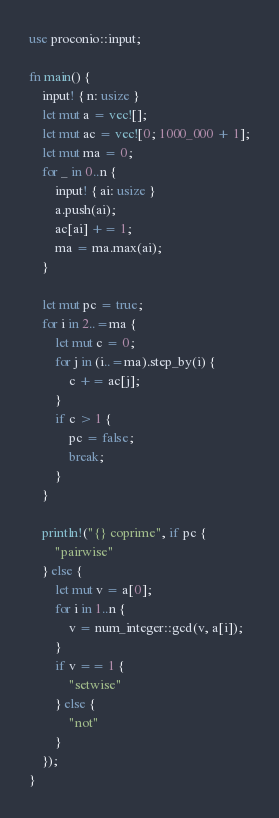Convert code to text. <code><loc_0><loc_0><loc_500><loc_500><_Rust_>use proconio::input;

fn main() {
    input! { n: usize }
    let mut a = vec![];
    let mut ac = vec![0; 1000_000 + 1];
    let mut ma = 0;
    for _ in 0..n {
        input! { ai: usize }
        a.push(ai);
        ac[ai] += 1;
        ma = ma.max(ai);
    }

    let mut pc = true;
    for i in 2..=ma {
        let mut c = 0;
        for j in (i..=ma).step_by(i) {
            c += ac[j];
        }
        if c > 1 {
            pc = false;
            break;
        }
    }

    println!("{} coprime", if pc {
        "pairwise"
    } else {
        let mut v = a[0];
        for i in 1..n {
            v = num_integer::gcd(v, a[i]);
        }
        if v == 1 {
            "setwise"
        } else {
            "not"
        }
    });
}
</code> 